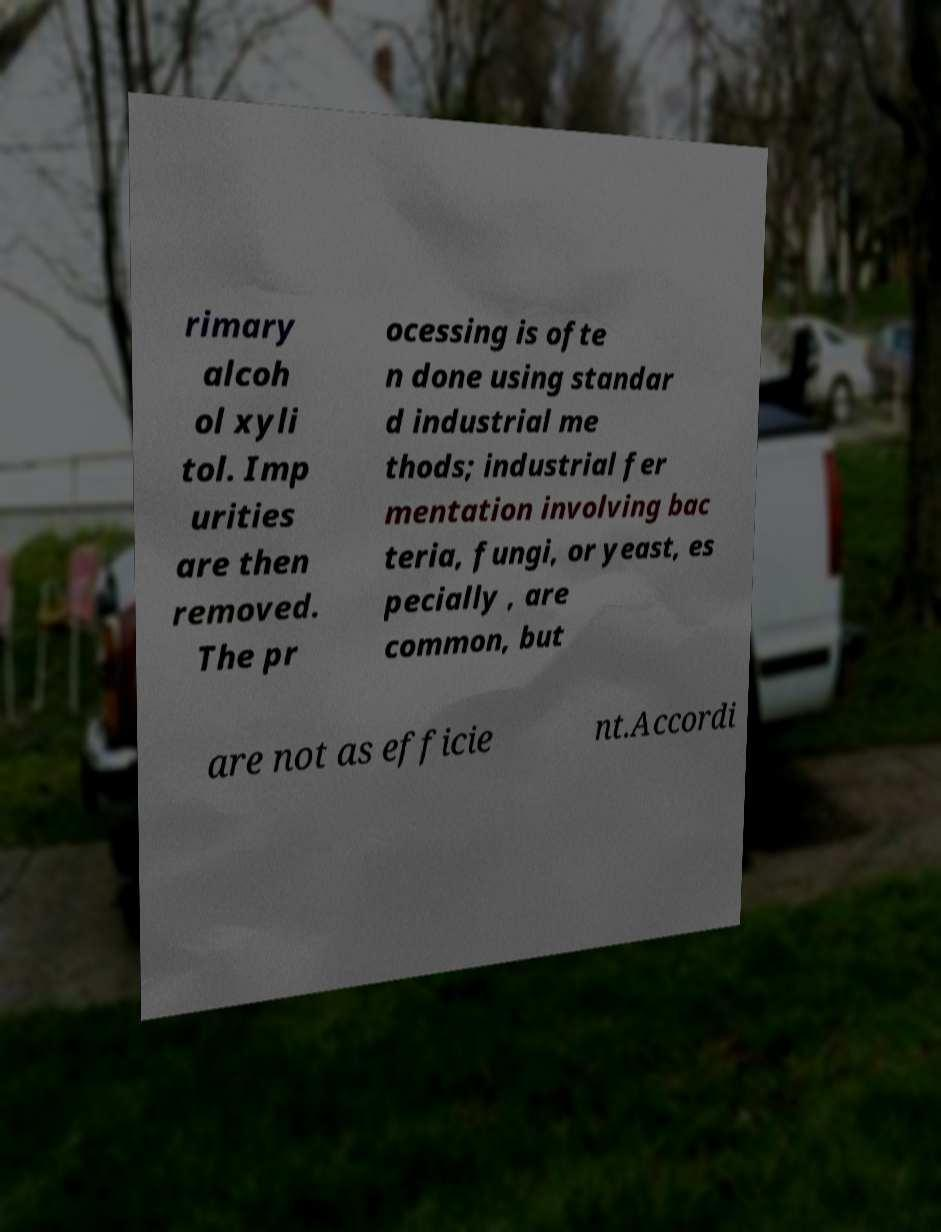Can you accurately transcribe the text from the provided image for me? rimary alcoh ol xyli tol. Imp urities are then removed. The pr ocessing is ofte n done using standar d industrial me thods; industrial fer mentation involving bac teria, fungi, or yeast, es pecially , are common, but are not as efficie nt.Accordi 